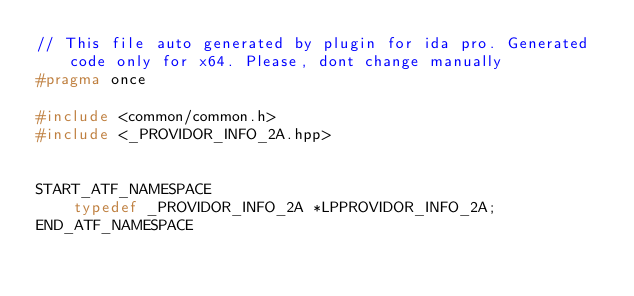<code> <loc_0><loc_0><loc_500><loc_500><_C++_>// This file auto generated by plugin for ida pro. Generated code only for x64. Please, dont change manually
#pragma once

#include <common/common.h>
#include <_PROVIDOR_INFO_2A.hpp>


START_ATF_NAMESPACE
    typedef _PROVIDOR_INFO_2A *LPPROVIDOR_INFO_2A;
END_ATF_NAMESPACE
</code> 